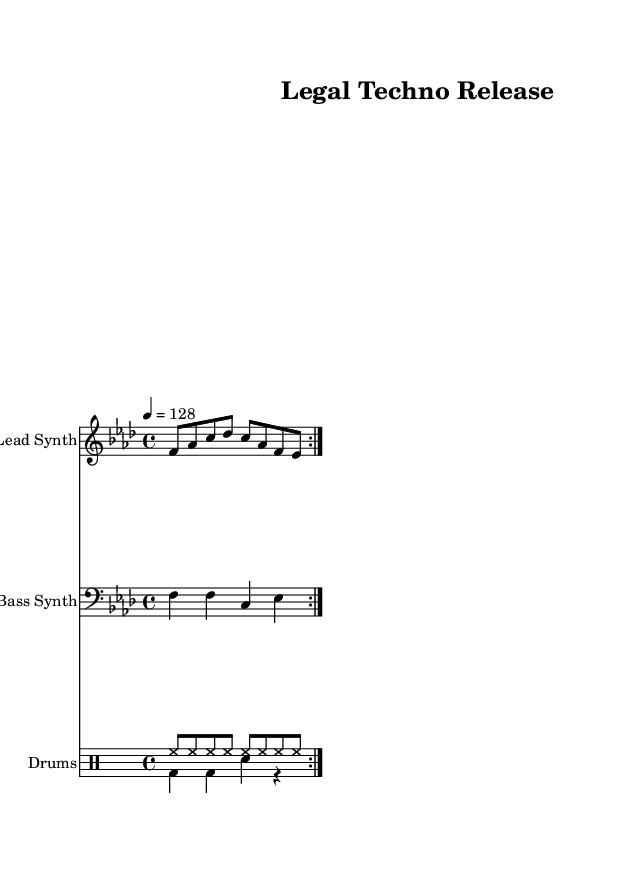What is the key signature of this music? The key signature is F minor, which has four flats (B flat, E flat, A flat, and D flat). This is indicated at the beginning of the staff.
Answer: F minor What is the time signature of the piece? The time signature shown is 4/4, indicating that there are four beats per measure and the quarter note gets one beat. This is typically marked at the beginning of the sheet music.
Answer: 4/4 What is the tempo marking for the music? The tempo marking is indicated to be 128 beats per minute, which is typically specified after the time signature. This fast tempo suits high-energy electronic dance music.
Answer: 128 How many measures are in the lead synth part? The lead synth part contains two measures, as indicated by the repeat sign and the musical notation. Each repeat of the notation reflects one measure, and there are two repetitions.
Answer: 2 What type of synthesizer is used for the bass part? The instrument specified for the bass part is a Bass Synth, mentioned in the label for the staff. This indicates that the sound is generated by a synthesizer suited for bass frequencies.
Answer: Bass Synth What rhythmic pattern is used for the drums? The drum pattern consists of a combination of hi-hat, bass drum, and snare drum, arranged in alternating measures that provide an upbeat rhythmic feel typical in electronic dance music. This can be inferred by analyzing the drum notation in the score.
Answer: Hi-hat/snare-bass 